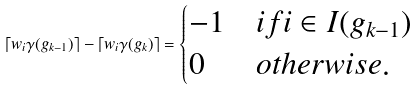<formula> <loc_0><loc_0><loc_500><loc_500>\lceil w _ { i } \gamma ( g _ { k - 1 } ) \rceil - \lceil w _ { i } \gamma ( g _ { k } ) \rceil = \begin{cases} - 1 & i f i \in I ( g _ { k - 1 } ) \\ 0 & o t h e r w i s e . \end{cases}</formula> 